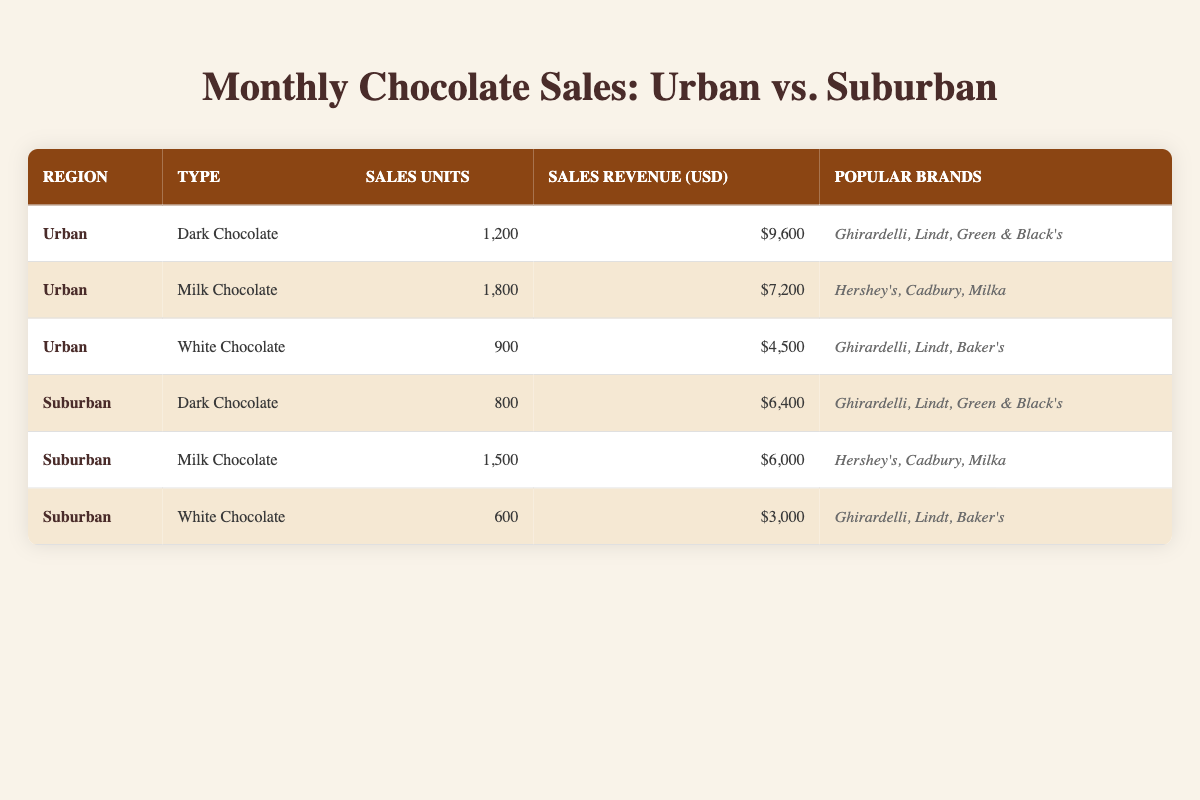What are the sales units for Milk Chocolate in Urban areas? The table shows the sales units specifically for Milk Chocolate in the Urban region, which is listed directly under that category. Referring to the row for Urban Milk Chocolate indicates there are 1,800 sales units.
Answer: 1,800 Which chocolate type generated the highest sales revenue in the Urban area? Examining the sales revenue for each type of chocolate in the Urban area, Dark Chocolate has $9,600, Milk Chocolate has $7,200, and White Chocolate has $4,500. Dark Chocolate has the highest revenue.
Answer: Dark Chocolate How many more sales units does Urban Milk Chocolate have compared to Suburban Milk Chocolate? In the Urban area, Milk Chocolate has 1,800 sales units, while in the Suburban area, it has 1,500 units. The difference is calculated as 1,800 - 1,500 = 300.
Answer: 300 Is the total sales revenue for Dark Chocolate higher in Urban or Suburban areas? The sales revenue for Urban Dark Chocolate is $9,600, while for Suburban, it is $6,400. Comparing these two values indicates that Urban Dark Chocolate has a higher sales revenue.
Answer: Yes What is the average sales revenue for White Chocolate in both regions? To find the average, first sum the sales revenue for White Chocolate from both regions: $4,500 (Urban) + $3,000 (Suburban) = $7,500. Since there are two regions, divide by 2, resulting in an average of $7,500 / 2 = $3,750.
Answer: $3,750 Which chocolate type has the lowest sales units in the Suburban area? Looking at the Suburban sales units, Dark Chocolate has 800, Milk Chocolate has 1,500, and White Chocolate has 600. Comparing these values shows that White Chocolate has the lowest units sold in the Suburban area.
Answer: White Chocolate How much total revenue was generated from chocolate sales in the Urban region? To find the total revenue, add together the revenues from all types of chocolate sold in the Urban area: $9,600 (Dark) + $7,200 (Milk) + $4,500 (White) = $21,300.
Answer: $21,300 Is Ghirardelli one of the popular brands for Milk Chocolate in the Urban area? The popular brands listed for Milk Chocolate in the Urban area are Hershey's, Cadbury, and Milka. Ghirardelli is not mentioned, indicating it is not a popular brand for that category.
Answer: No Which region has more popular brands for White Chocolate? The popular brands for White Chocolate in both regions are Ghirardelli, Lindt, and Baker's in Urban, and the same in Suburban. Both regions have an equal number of popular brands, which is 3.
Answer: Equal 